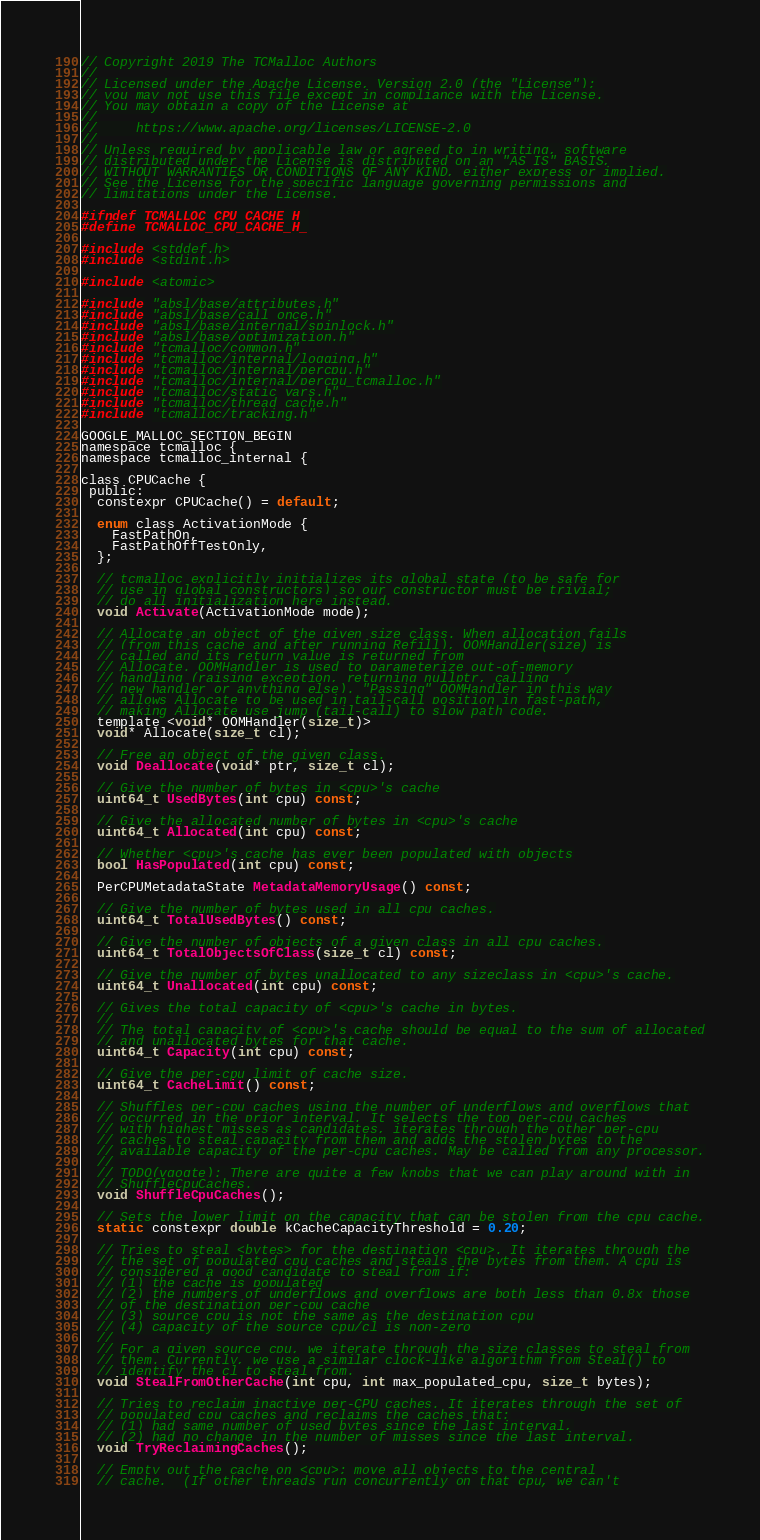Convert code to text. <code><loc_0><loc_0><loc_500><loc_500><_C_>// Copyright 2019 The TCMalloc Authors
//
// Licensed under the Apache License, Version 2.0 (the "License");
// you may not use this file except in compliance with the License.
// You may obtain a copy of the License at
//
//     https://www.apache.org/licenses/LICENSE-2.0
//
// Unless required by applicable law or agreed to in writing, software
// distributed under the License is distributed on an "AS IS" BASIS,
// WITHOUT WARRANTIES OR CONDITIONS OF ANY KIND, either express or implied.
// See the License for the specific language governing permissions and
// limitations under the License.

#ifndef TCMALLOC_CPU_CACHE_H_
#define TCMALLOC_CPU_CACHE_H_

#include <stddef.h>
#include <stdint.h>

#include <atomic>

#include "absl/base/attributes.h"
#include "absl/base/call_once.h"
#include "absl/base/internal/spinlock.h"
#include "absl/base/optimization.h"
#include "tcmalloc/common.h"
#include "tcmalloc/internal/logging.h"
#include "tcmalloc/internal/percpu.h"
#include "tcmalloc/internal/percpu_tcmalloc.h"
#include "tcmalloc/static_vars.h"
#include "tcmalloc/thread_cache.h"
#include "tcmalloc/tracking.h"

GOOGLE_MALLOC_SECTION_BEGIN
namespace tcmalloc {
namespace tcmalloc_internal {

class CPUCache {
 public:
  constexpr CPUCache() = default;

  enum class ActivationMode {
    FastPathOn,
    FastPathOffTestOnly,
  };

  // tcmalloc explicitly initializes its global state (to be safe for
  // use in global constructors) so our constructor must be trivial;
  // do all initialization here instead.
  void Activate(ActivationMode mode);

  // Allocate an object of the given size class. When allocation fails
  // (from this cache and after running Refill), OOMHandler(size) is
  // called and its return value is returned from
  // Allocate. OOMHandler is used to parameterize out-of-memory
  // handling (raising exception, returning nullptr, calling
  // new_handler or anything else). "Passing" OOMHandler in this way
  // allows Allocate to be used in tail-call position in fast-path,
  // making Allocate use jump (tail-call) to slow path code.
  template <void* OOMHandler(size_t)>
  void* Allocate(size_t cl);

  // Free an object of the given class.
  void Deallocate(void* ptr, size_t cl);

  // Give the number of bytes in <cpu>'s cache
  uint64_t UsedBytes(int cpu) const;

  // Give the allocated number of bytes in <cpu>'s cache
  uint64_t Allocated(int cpu) const;

  // Whether <cpu>'s cache has ever been populated with objects
  bool HasPopulated(int cpu) const;

  PerCPUMetadataState MetadataMemoryUsage() const;

  // Give the number of bytes used in all cpu caches.
  uint64_t TotalUsedBytes() const;

  // Give the number of objects of a given class in all cpu caches.
  uint64_t TotalObjectsOfClass(size_t cl) const;

  // Give the number of bytes unallocated to any sizeclass in <cpu>'s cache.
  uint64_t Unallocated(int cpu) const;

  // Gives the total capacity of <cpu>'s cache in bytes.
  //
  // The total capacity of <cpu>'s cache should be equal to the sum of allocated
  // and unallocated bytes for that cache.
  uint64_t Capacity(int cpu) const;

  // Give the per-cpu limit of cache size.
  uint64_t CacheLimit() const;

  // Shuffles per-cpu caches using the number of underflows and overflows that
  // occurred in the prior interval. It selects the top per-cpu caches
  // with highest misses as candidates, iterates through the other per-cpu
  // caches to steal capacity from them and adds the stolen bytes to the
  // available capacity of the per-cpu caches. May be called from any processor.
  //
  // TODO(vgogte): There are quite a few knobs that we can play around with in
  // ShuffleCpuCaches.
  void ShuffleCpuCaches();

  // Sets the lower limit on the capacity that can be stolen from the cpu cache.
  static constexpr double kCacheCapacityThreshold = 0.20;

  // Tries to steal <bytes> for the destination <cpu>. It iterates through the
  // the set of populated cpu caches and steals the bytes from them. A cpu is
  // considered a good candidate to steal from if:
  // (1) the cache is populated
  // (2) the numbers of underflows and overflows are both less than 0.8x those
  // of the destination per-cpu cache
  // (3) source cpu is not the same as the destination cpu
  // (4) capacity of the source cpu/cl is non-zero
  //
  // For a given source cpu, we iterate through the size classes to steal from
  // them. Currently, we use a similar clock-like algorithm from Steal() to
  // identify the cl to steal from.
  void StealFromOtherCache(int cpu, int max_populated_cpu, size_t bytes);

  // Tries to reclaim inactive per-CPU caches. It iterates through the set of
  // populated cpu caches and reclaims the caches that:
  // (1) had same number of used bytes since the last interval,
  // (2) had no change in the number of misses since the last interval.
  void TryReclaimingCaches();

  // Empty out the cache on <cpu>; move all objects to the central
  // cache.  (If other threads run concurrently on that cpu, we can't</code> 